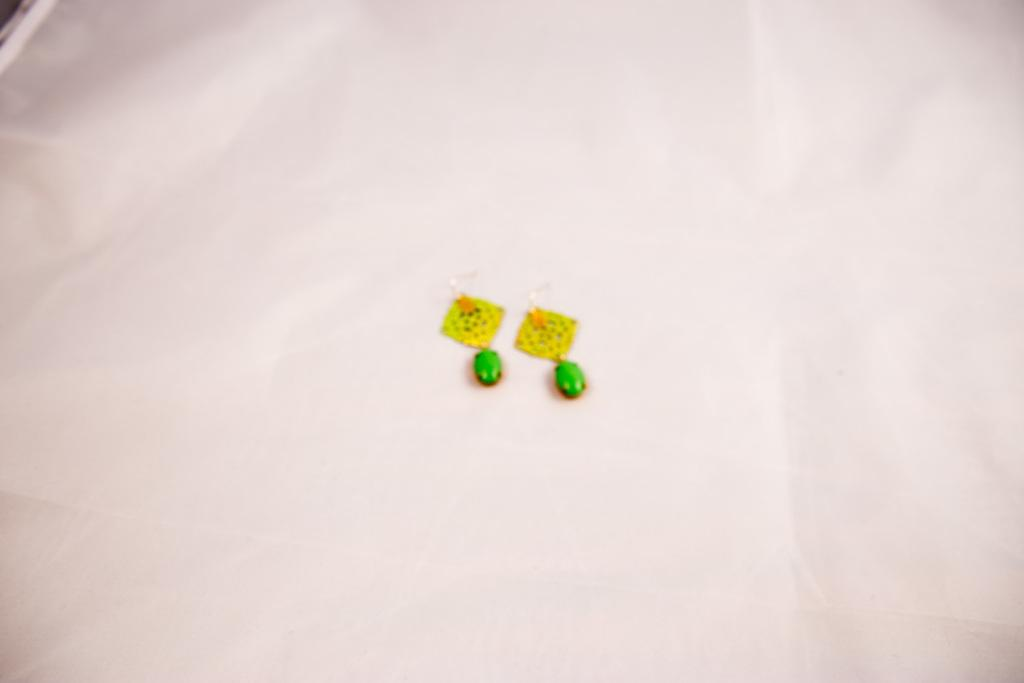What type of accessory is featured in the image? There are colorful earrings in the image. What is the color of the surface on which the earrings are placed? The earrings are on a white surface. What type of linen can be seen in the image? There is no linen present in the image; it only features colorful earrings on a white surface. What color are the eyes of the person wearing the earrings in the image? There is no person wearing the earrings in the image, so their eye color cannot be determined. 